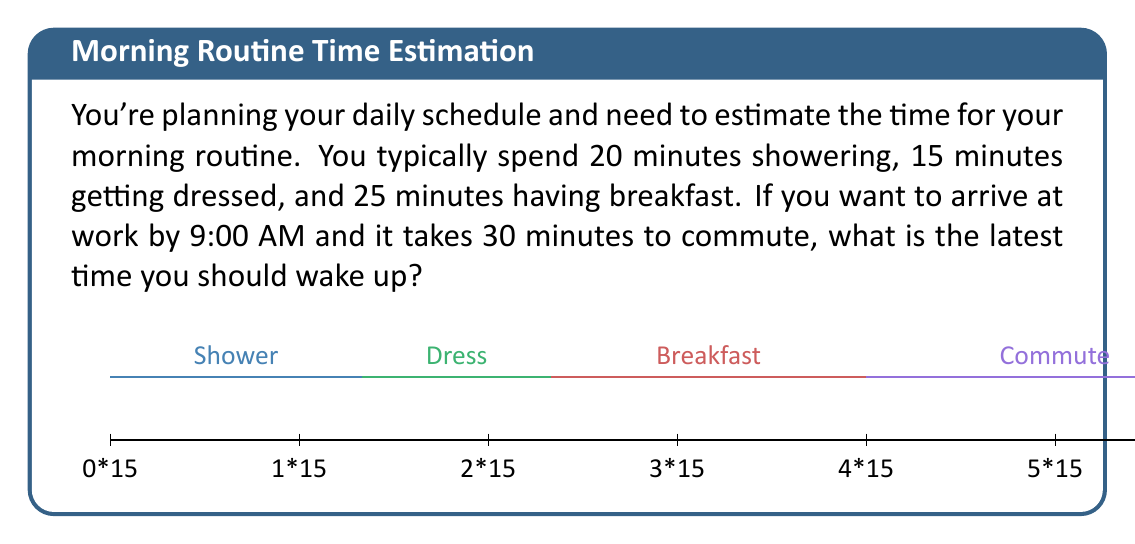Teach me how to tackle this problem. Let's break this down step-by-step:

1) First, let's calculate the total time needed for the morning routine:
   Shower: 20 minutes
   Getting dressed: 15 minutes
   Breakfast: 25 minutes
   $$20 + 15 + 25 = 60$$ minutes

2) Now, add the commute time:
   Morning routine: 60 minutes
   Commute: 30 minutes
   $$60 + 30 = 90$$ minutes

3) We know you need to arrive at work by 9:00 AM. To find the latest wake-up time, we need to subtract 90 minutes from 9:00 AM.

4) 90 minutes is equal to 1 hour and 30 minutes.
   $$9:00 \text{ AM} - 1:30 = 7:30 \text{ AM}$$

Therefore, the latest time you should wake up is 7:30 AM to ensure you arrive at work by 9:00 AM.
Answer: 7:30 AM 